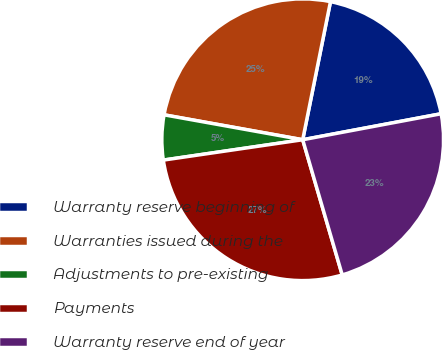<chart> <loc_0><loc_0><loc_500><loc_500><pie_chart><fcel>Warranty reserve beginning of<fcel>Warranties issued during the<fcel>Adjustments to pre-existing<fcel>Payments<fcel>Warranty reserve end of year<nl><fcel>18.89%<fcel>25.33%<fcel>5.14%<fcel>27.22%<fcel>23.43%<nl></chart> 